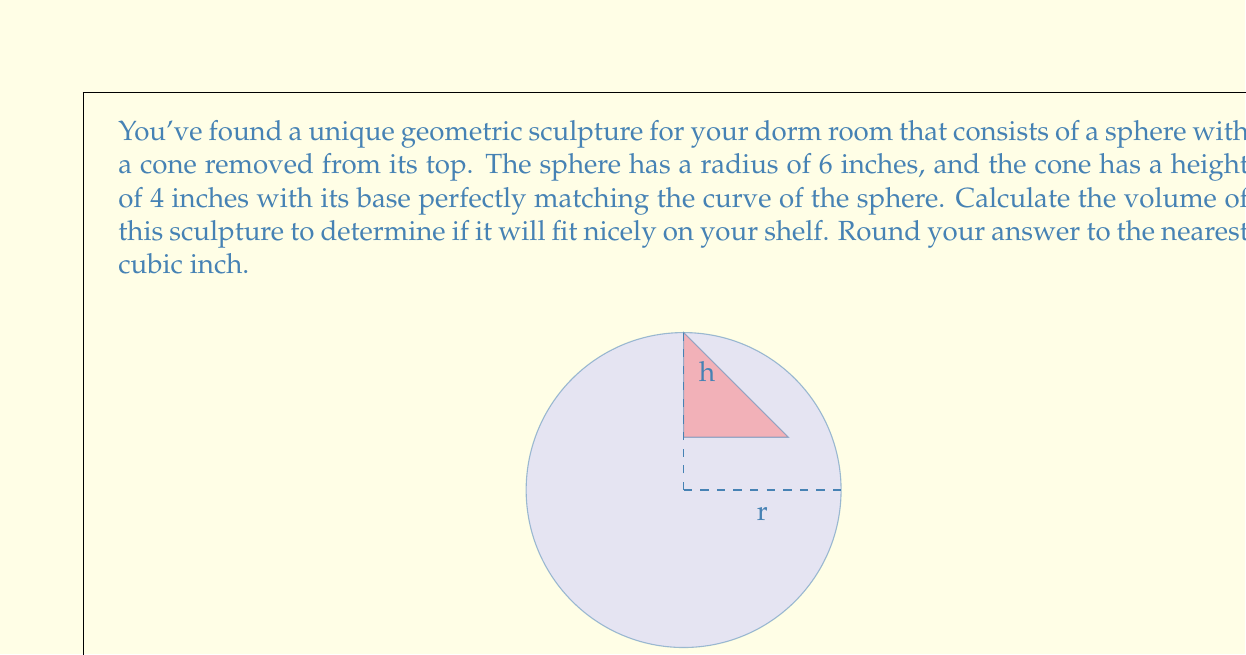Provide a solution to this math problem. To solve this problem, we need to calculate the volume of the sphere and subtract the volume of the cone. Let's break it down step by step:

1) Volume of a sphere: $V_{sphere} = \frac{4}{3}\pi r^3$
   With $r = 6$ inches, $V_{sphere} = \frac{4}{3}\pi 6^3 = 288\pi$ cubic inches

2) For the cone, we need to first find its radius. The base of the cone forms a circle on the sphere's surface. We can use the Pythagorean theorem:

   $r^2 = (r-h)^2 + R^2$

   Where $r$ is the sphere's radius (6 inches), $h$ is the cone's height (4 inches), and $R$ is the cone's base radius.

   $6^2 = (6-4)^2 + R^2$
   $36 = 4 + R^2$
   $R^2 = 32$
   $R = \sqrt{32} = 4\sqrt{2}$ inches

3) Now we can calculate the volume of the cone:
   $V_{cone} = \frac{1}{3}\pi R^2 h = \frac{1}{3}\pi (4\sqrt{2})^2 4 = \frac{32}{3}\pi$ cubic inches

4) The volume of the sculpture is the difference between the sphere and cone volumes:

   $V_{sculpture} = V_{sphere} - V_{cone} = 288\pi - \frac{32}{3}\pi = \frac{832}{3}\pi$ cubic inches

5) Converting to a numeric value and rounding to the nearest cubic inch:
   $\frac{832}{3}\pi \approx 871.81$ cubic inches
   Rounded to the nearest cubic inch: 872 cubic inches
Answer: 872 cubic inches 